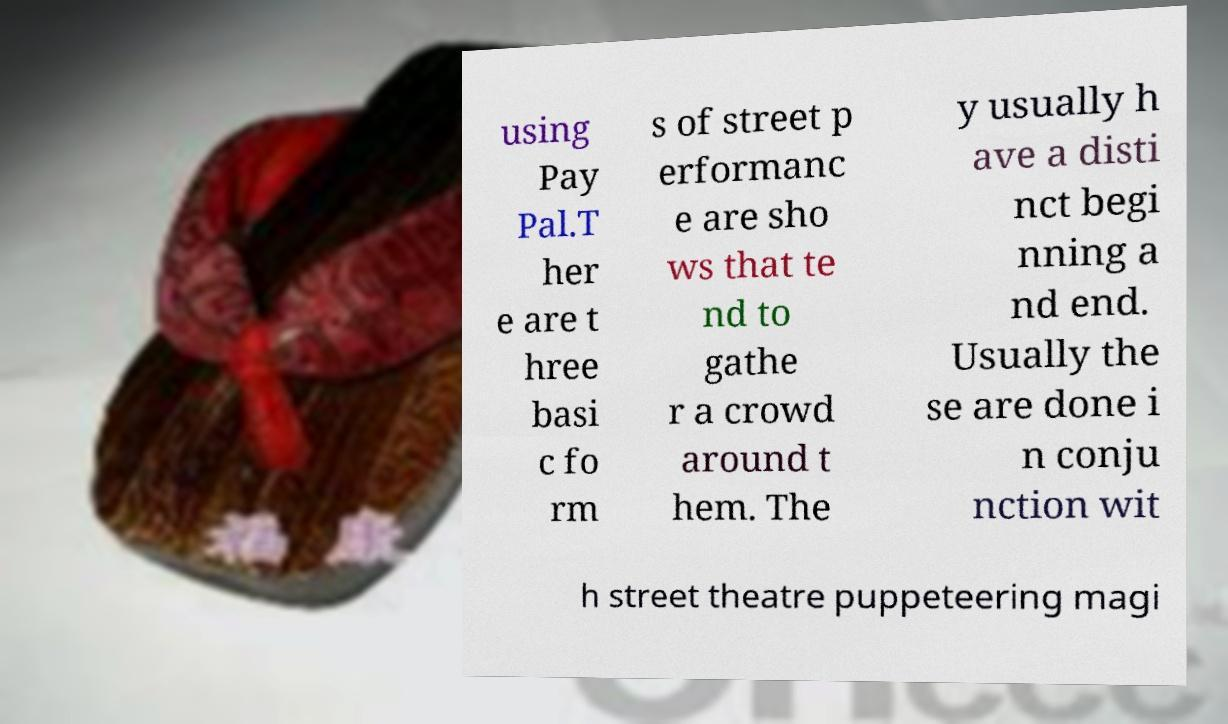For documentation purposes, I need the text within this image transcribed. Could you provide that? using Pay Pal.T her e are t hree basi c fo rm s of street p erformanc e are sho ws that te nd to gathe r a crowd around t hem. The y usually h ave a disti nct begi nning a nd end. Usually the se are done i n conju nction wit h street theatre puppeteering magi 